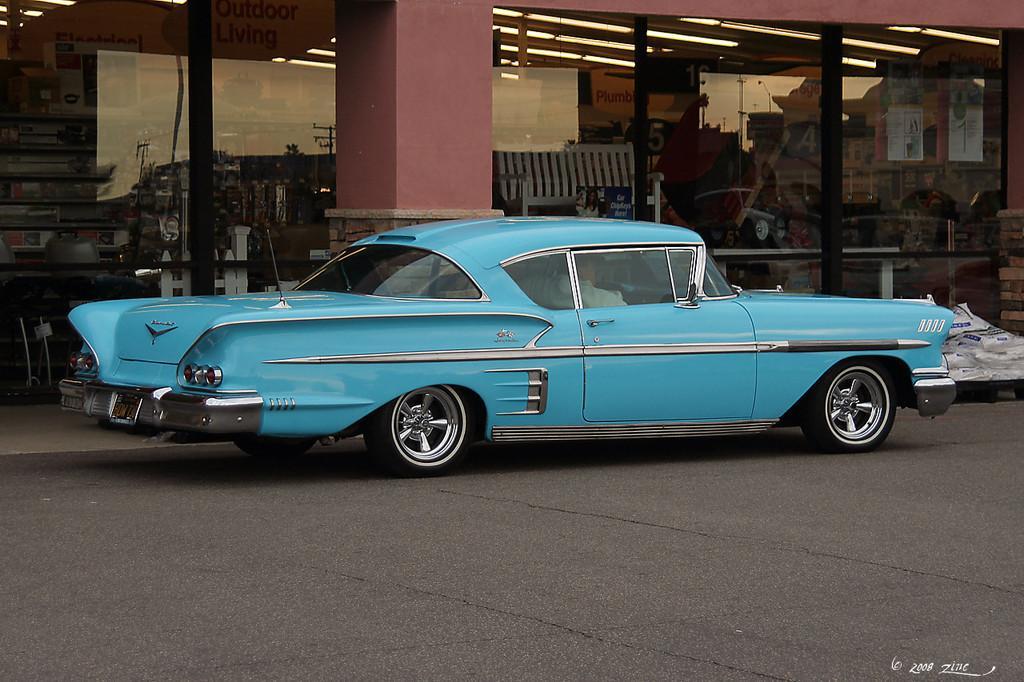Can you describe this image briefly? In this picture we can see a car on the road, bench, lights, some objects, glass with the reflection of buildings, trees, poles and the sky on it. 